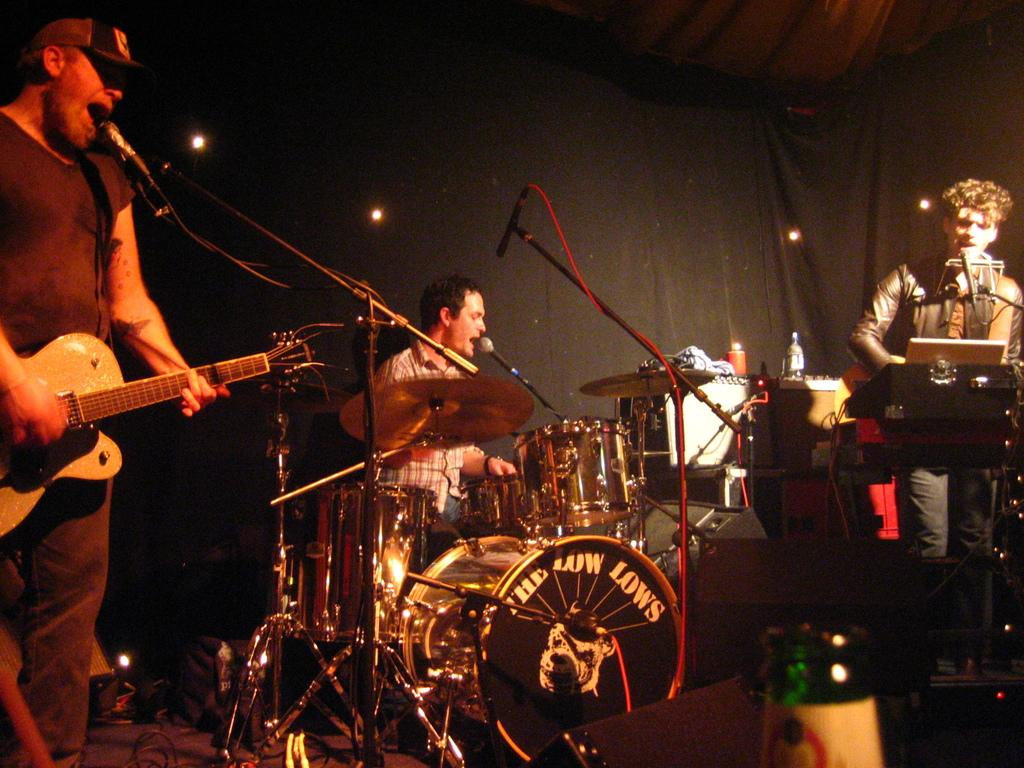How many people are in the image? There are three persons in the image. What are the three persons doing in the image? Each of the three persons is playing a musical instrument. Can you see any flowers in the image? There is no mention of flowers in the image; the focus is on the three persons playing musical instruments. 